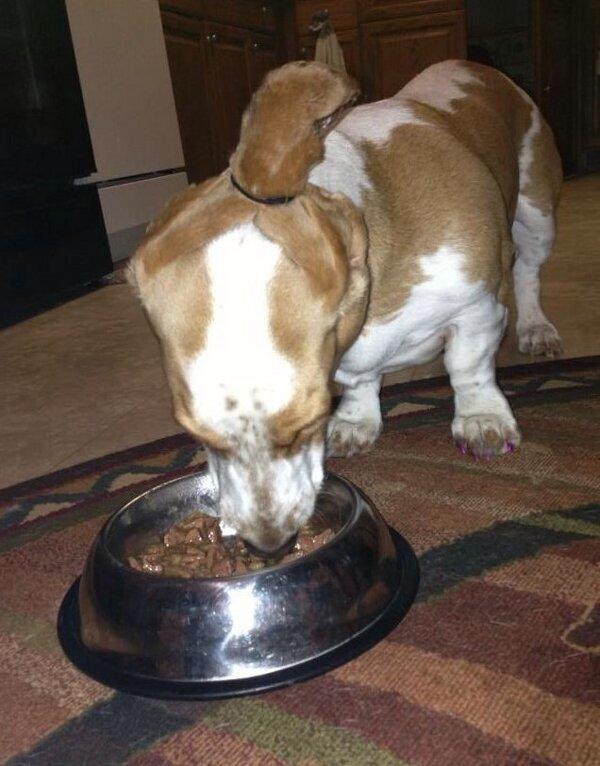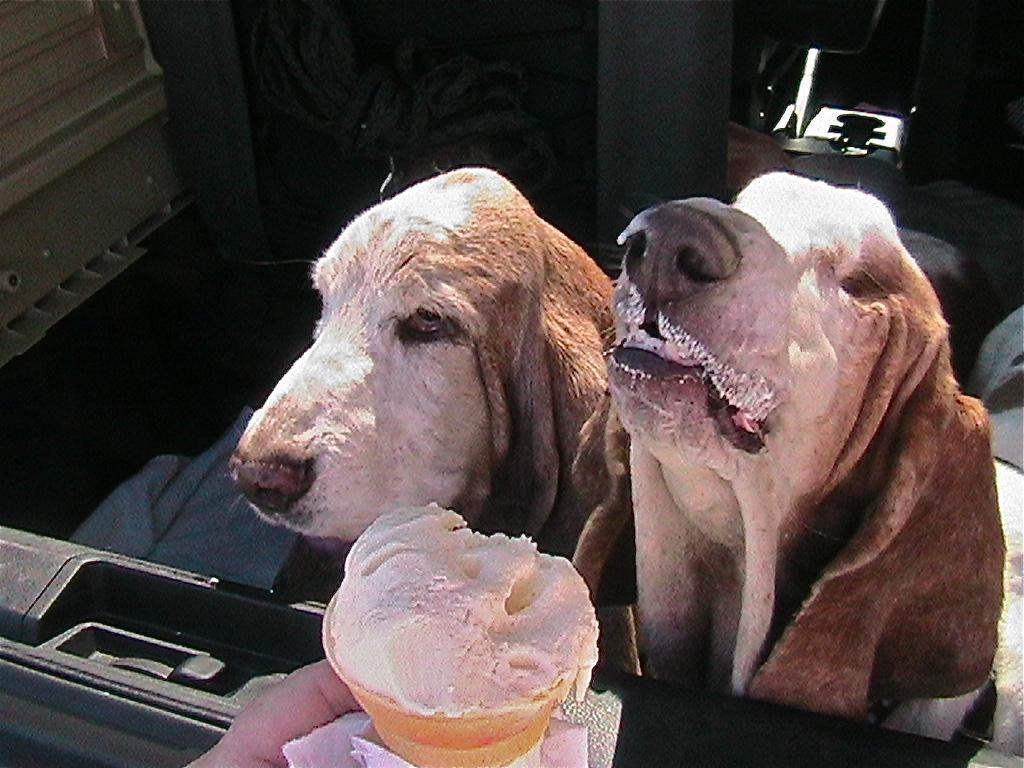The first image is the image on the left, the second image is the image on the right. Given the left and right images, does the statement "A dog is eating in both images," hold true? Answer yes or no. Yes. The first image is the image on the left, the second image is the image on the right. Given the left and right images, does the statement "Each image includes exactly one basset hound, which faces mostly forward, and at least one hound has an object in front of part of its face and touching part of its face." hold true? Answer yes or no. No. 